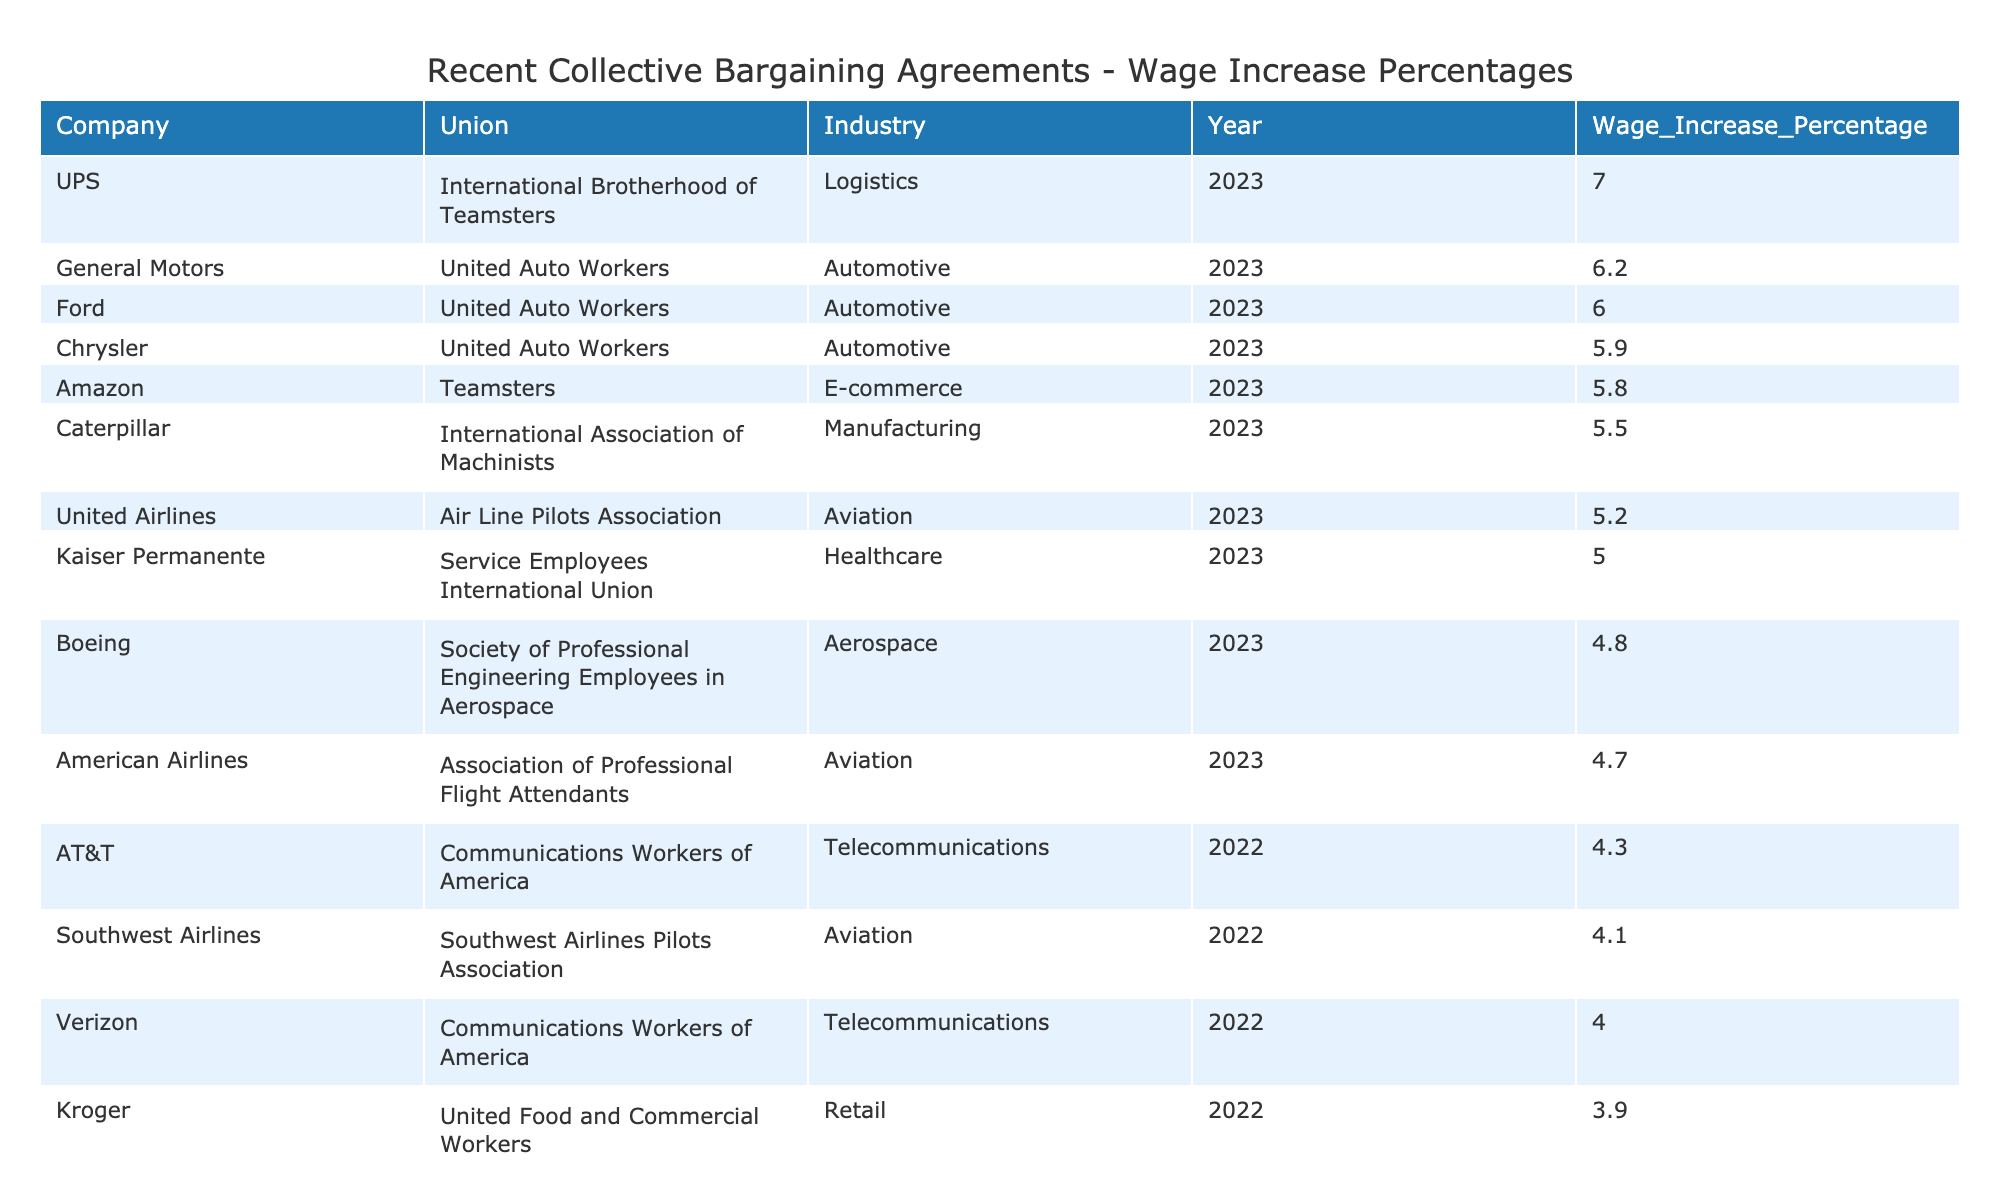What is the highest wage increase percentage negotiated in 2023? The highest wage increase percentage in 2023 is listed in the table. By reviewing the entries for that year, I see that UPS negotiated a wage increase of 7.0%.
Answer: 7.0% Which company negotiated a wage increase of 5.5% in 2023? Looking through the 2023 entries in the table, I find that Caterpillar negotiated a wage increase of 5.5%.
Answer: Caterpillar How many companies negotiated wage increases in 2022? The table shows the entries for 2022. By counting them, I see there are five entries for that year (Southwest Airlines, Kroger, AT&T, Safeway, and Verizon).
Answer: 5 What is the average wage increase percentage for the companies that negotiated in 2023? To find the average, I will sum the wage increase percentages for 2023 (6.2 + 5.8 + 5.0 + 7.0 + 5.5 + 5.9 + 6.0 + 5.2) which equals 41.6%, then divide by the 8 companies that negotiated in that year, giving an average of 41.6/8 = 5.2%.
Answer: 5.2% Did any company negotiate a wage increase less than 4%? By scanning the table, I find that the lowest wage increase percentage for any year is 3.7% from Safeway in 2022, which confirms that yes, at least one company negotiated less than 4%.
Answer: Yes Which union negotiated the lowest wage increase in 2022? Reviewing the wage increases for 2022, I see that both Kroger (3.9%) and Safeway (3.7%) had the lowest increases. Therefore, the union associated with Safeway negotiated the lowest wage increase.
Answer: United Food and Commercial Workers What was the wage increase percentage for the Aviation industry in 2023? I need to look through the 2023 entries in the table specifically for the Aviation industry. American Airlines had a wage increase of 4.7%, and United Airlines had an increase of 5.2%. Thus, the highest was 5.2% from United Airlines.
Answer: 5.2% Which industries had companies negotiating wage increases in both 2022 and 2023? I examine the table for industries that appear in both years. The Automotive and Retail industries are present in both, with companies negotiating in those industries for both years.
Answer: Automotive and Retail Calculate the difference in wage increase percentage between UPS and Amazon in 2023. The wage increase for UPS in 2023 is 7.0%, and for Amazon, it is 5.8%. The difference is calculated as 7.0% - 5.8% = 1.2%.
Answer: 1.2% How many unions represented companies that negotiated a wage increase of 5% or more in 2023? I will list the companies with increases of 5% and more from 2023 (UPS, General Motors, Ford, and Caterpillar). Each of these companies has a different union, which totals four unions.
Answer: 4 